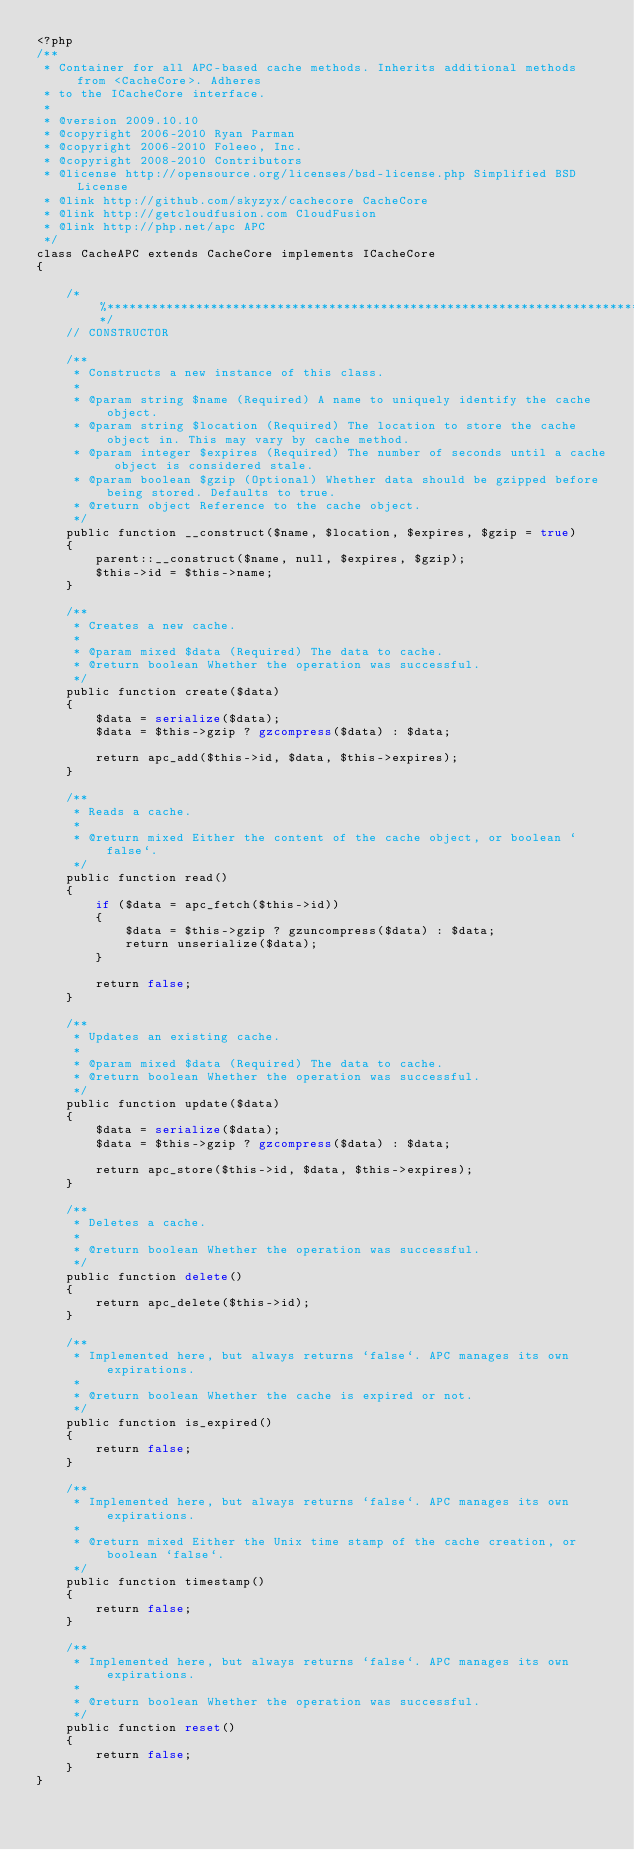Convert code to text. <code><loc_0><loc_0><loc_500><loc_500><_PHP_><?php
/**
 * Container for all APC-based cache methods. Inherits additional methods from <CacheCore>. Adheres
 * to the ICacheCore interface.
 *
 * @version 2009.10.10
 * @copyright 2006-2010 Ryan Parman
 * @copyright 2006-2010 Foleeo, Inc.
 * @copyright 2008-2010 Contributors
 * @license http://opensource.org/licenses/bsd-license.php Simplified BSD License
 * @link http://github.com/skyzyx/cachecore CacheCore
 * @link http://getcloudfusion.com CloudFusion
 * @link http://php.net/apc APC
 */
class CacheAPC extends CacheCore implements ICacheCore
{

	/*%******************************************************************************************%*/
	// CONSTRUCTOR

	/**
	 * Constructs a new instance of this class.
	 *
	 * @param string $name (Required) A name to uniquely identify the cache object.
	 * @param string $location (Required) The location to store the cache object in. This may vary by cache method.
	 * @param integer $expires (Required) The number of seconds until a cache object is considered stale.
	 * @param boolean $gzip (Optional) Whether data should be gzipped before being stored. Defaults to true.
	 * @return object Reference to the cache object.
	 */
	public function __construct($name, $location, $expires, $gzip = true)
	{
		parent::__construct($name, null, $expires, $gzip);
		$this->id = $this->name;
	}

	/**
	 * Creates a new cache.
	 *
	 * @param mixed $data (Required) The data to cache.
	 * @return boolean Whether the operation was successful.
	 */
	public function create($data)
	{
		$data = serialize($data);
		$data = $this->gzip ? gzcompress($data) : $data;

		return apc_add($this->id, $data, $this->expires);
	}

	/**
	 * Reads a cache.
	 *
	 * @return mixed Either the content of the cache object, or boolean `false`.
	 */
	public function read()
	{
		if ($data = apc_fetch($this->id))
		{
			$data = $this->gzip ? gzuncompress($data) : $data;
			return unserialize($data);
		}

		return false;
	}

	/**
	 * Updates an existing cache.
	 *
	 * @param mixed $data (Required) The data to cache.
	 * @return boolean Whether the operation was successful.
	 */
	public function update($data)
	{
		$data = serialize($data);
		$data = $this->gzip ? gzcompress($data) : $data;

		return apc_store($this->id, $data, $this->expires);
	}

	/**
	 * Deletes a cache.
	 *
	 * @return boolean Whether the operation was successful.
	 */
	public function delete()
	{
		return apc_delete($this->id);
	}

	/**
	 * Implemented here, but always returns `false`. APC manages its own expirations.
	 *
	 * @return boolean Whether the cache is expired or not.
	 */
	public function is_expired()
	{
		return false;
	}

	/**
	 * Implemented here, but always returns `false`. APC manages its own expirations.
	 *
	 * @return mixed Either the Unix time stamp of the cache creation, or boolean `false`.
	 */
	public function timestamp()
	{
		return false;
	}

	/**
	 * Implemented here, but always returns `false`. APC manages its own expirations.
	 *
	 * @return boolean Whether the operation was successful.
	 */
	public function reset()
	{
		return false;
	}
}
</code> 